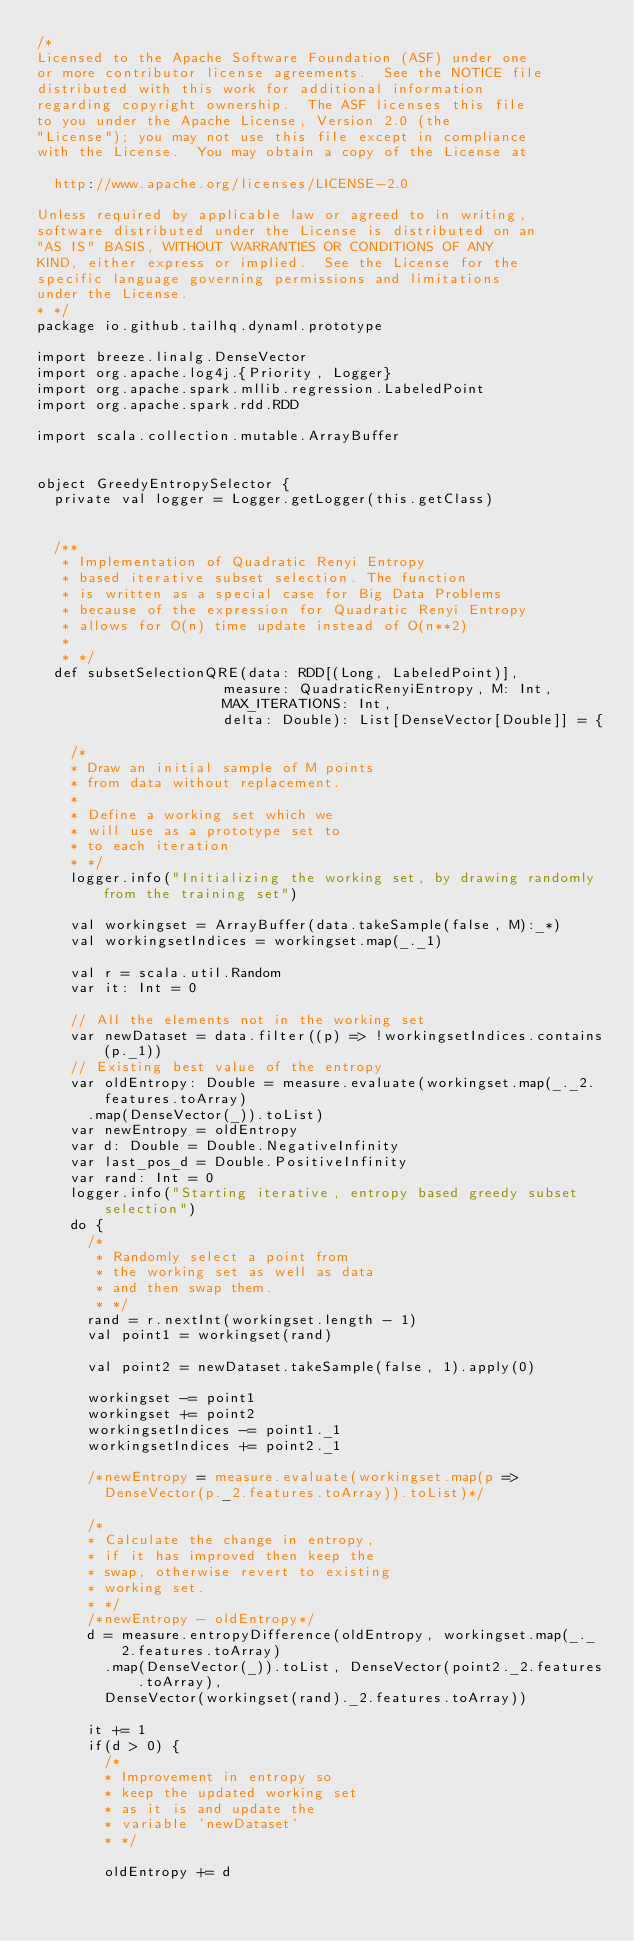<code> <loc_0><loc_0><loc_500><loc_500><_Scala_>/*
Licensed to the Apache Software Foundation (ASF) under one
or more contributor license agreements.  See the NOTICE file
distributed with this work for additional information
regarding copyright ownership.  The ASF licenses this file
to you under the Apache License, Version 2.0 (the
"License"); you may not use this file except in compliance
with the License.  You may obtain a copy of the License at

  http://www.apache.org/licenses/LICENSE-2.0

Unless required by applicable law or agreed to in writing,
software distributed under the License is distributed on an
"AS IS" BASIS, WITHOUT WARRANTIES OR CONDITIONS OF ANY
KIND, either express or implied.  See the License for the
specific language governing permissions and limitations
under the License.
* */
package io.github.tailhq.dynaml.prototype

import breeze.linalg.DenseVector
import org.apache.log4j.{Priority, Logger}
import org.apache.spark.mllib.regression.LabeledPoint
import org.apache.spark.rdd.RDD

import scala.collection.mutable.ArrayBuffer


object GreedyEntropySelector {
  private val logger = Logger.getLogger(this.getClass)


  /**
   * Implementation of Quadratic Renyi Entropy
   * based iterative subset selection. The function
   * is written as a special case for Big Data Problems
   * because of the expression for Quadratic Renyi Entropy
   * allows for O(n) time update instead of O(n**2)
   *
   * */
  def subsetSelectionQRE(data: RDD[(Long, LabeledPoint)],
                      measure: QuadraticRenyiEntropy, M: Int,
                      MAX_ITERATIONS: Int,
                      delta: Double): List[DenseVector[Double]] = {

    /*
    * Draw an initial sample of M points
    * from data without replacement.
    *
    * Define a working set which we
    * will use as a prototype set to
    * to each iteration
    * */
    logger.info("Initializing the working set, by drawing randomly from the training set")

    val workingset = ArrayBuffer(data.takeSample(false, M):_*)
    val workingsetIndices = workingset.map(_._1)

    val r = scala.util.Random
    var it: Int = 0

    // All the elements not in the working set
    var newDataset = data.filter((p) => !workingsetIndices.contains(p._1))
    // Existing best value of the entropy
    var oldEntropy: Double = measure.evaluate(workingset.map(_._2.features.toArray)
      .map(DenseVector(_)).toList)
    var newEntropy = oldEntropy
    var d: Double = Double.NegativeInfinity
    var last_pos_d = Double.PositiveInfinity
    var rand: Int = 0
    logger.info("Starting iterative, entropy based greedy subset selection")
    do {
      /*
       * Randomly select a point from
       * the working set as well as data
       * and then swap them.
       * */
      rand = r.nextInt(workingset.length - 1)
      val point1 = workingset(rand)

      val point2 = newDataset.takeSample(false, 1).apply(0)

      workingset -= point1
      workingset += point2
      workingsetIndices -= point1._1
      workingsetIndices += point2._1

      /*newEntropy = measure.evaluate(workingset.map(p =>
        DenseVector(p._2.features.toArray)).toList)*/

      /*
      * Calculate the change in entropy,
      * if it has improved then keep the
      * swap, otherwise revert to existing
      * working set.
      * */
      /*newEntropy - oldEntropy*/
      d = measure.entropyDifference(oldEntropy, workingset.map(_._2.features.toArray)
        .map(DenseVector(_)).toList, DenseVector(point2._2.features.toArray),
        DenseVector(workingset(rand)._2.features.toArray))

      it += 1
      if(d > 0) {
        /*
        * Improvement in entropy so
        * keep the updated working set
        * as it is and update the
        * variable 'newDataset'
        * */

        oldEntropy += d</code> 